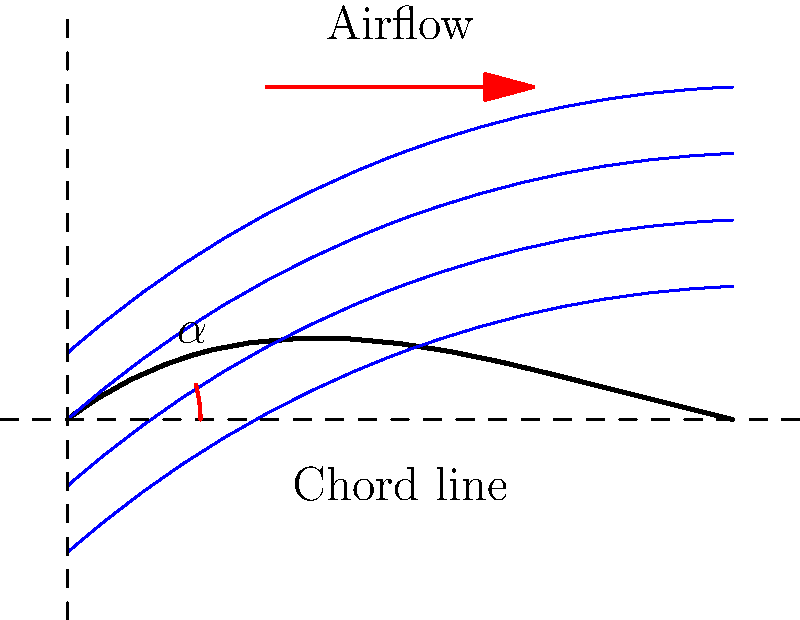In your latest abstract painting inspired by fluid dynamics, you've incorporated streamlines around an airfoil. If the angle of attack ($\alpha$) is increased, how would the flow pattern change, and what effect might this have on lift? To understand the effect of increasing the angle of attack on the flow pattern and lift, let's break it down step-by-step:

1. Angle of attack ($\alpha$): This is the angle between the chord line of the airfoil and the direction of the oncoming airflow.

2. Current flow pattern:
   - The streamlines are closer together above the airfoil.
   - They are more spread out below the airfoil.
   - This indicates higher velocity above and lower velocity below.

3. Bernoulli's principle: As velocity increases, pressure decreases, and vice versa.

4. Current lift generation:
   - Higher velocity above = Lower pressure above
   - Lower velocity below = Higher pressure below
   - The pressure difference creates lift

5. Increasing angle of attack:
   - The leading edge of the airfoil tilts upward more.
   - This causes the air to travel a longer path over the top surface.
   - It also creates a greater obstruction to the flow underneath.

6. Changes in flow pattern:
   - Streamlines above the airfoil become even more compressed.
   - Streamlines below become more spread out.
   - The curvature of the streamlines increases.

7. Effect on lift:
   - The velocity difference between upper and lower surfaces increases.
   - This leads to a greater pressure difference.
   - As a result, lift increases.

8. Limitation:
   - This effect continues up to a critical angle of attack.
   - Beyond this point, flow separation occurs, leading to stall and loss of lift.

In the context of abstract art, this phenomenon could be visualized as increasing tension and contrast between the upper and lower portions of the painting, symbolizing the growing pressure difference and lift.
Answer: Increased streamline curvature and compression above the airfoil, leading to greater lift. 